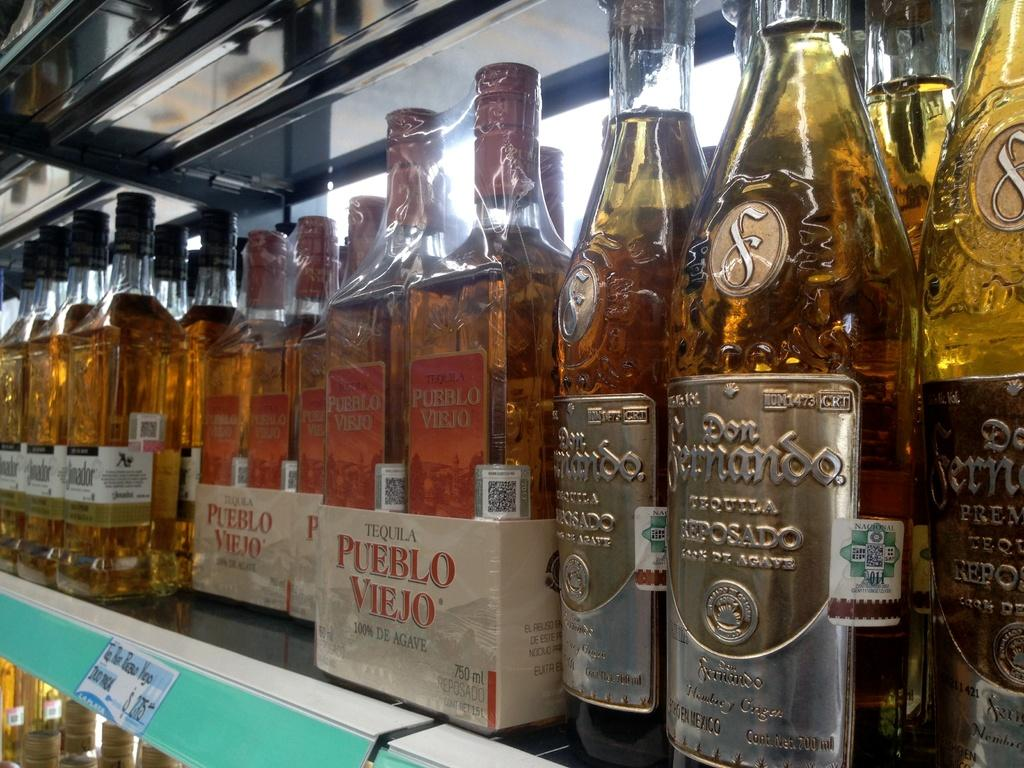What is the main subject of the image? The main subject of the image is a group of wine bottles. What is inside the wine bottles? The wine bottles contain liquid. How are the wine bottles arranged in the image? The wine bottles are in a rack. Are there any other racks in the image? Yes, there is another rack in the image. What is present in the second rack? There are bottles in the second rack. How many ants can be seen crawling on the wine bottles in the image? There are no ants present in the image; it only features wine bottles in racks. 